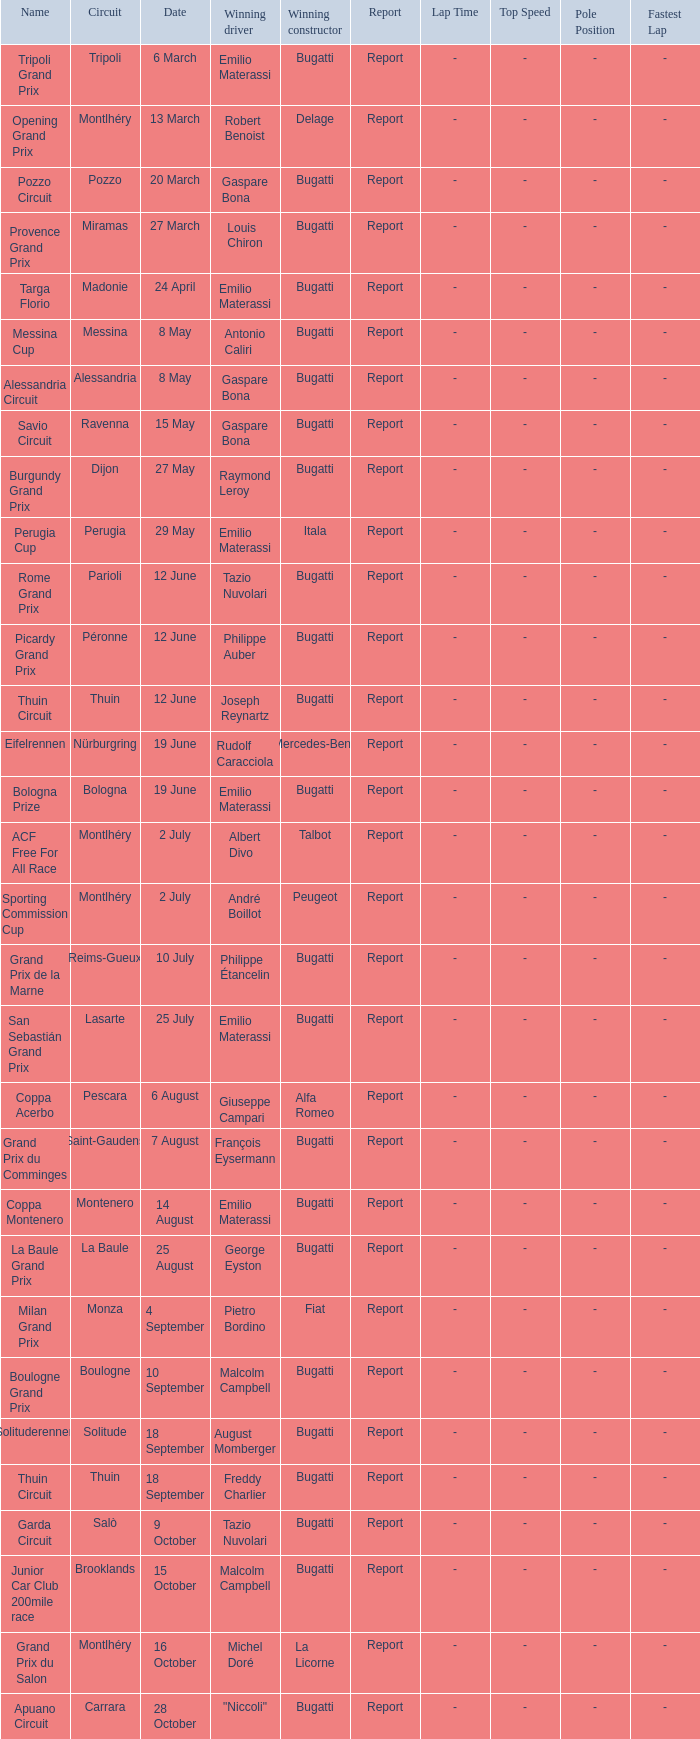Which constructor triumphed at the circuit of parioli? Bugatti. 